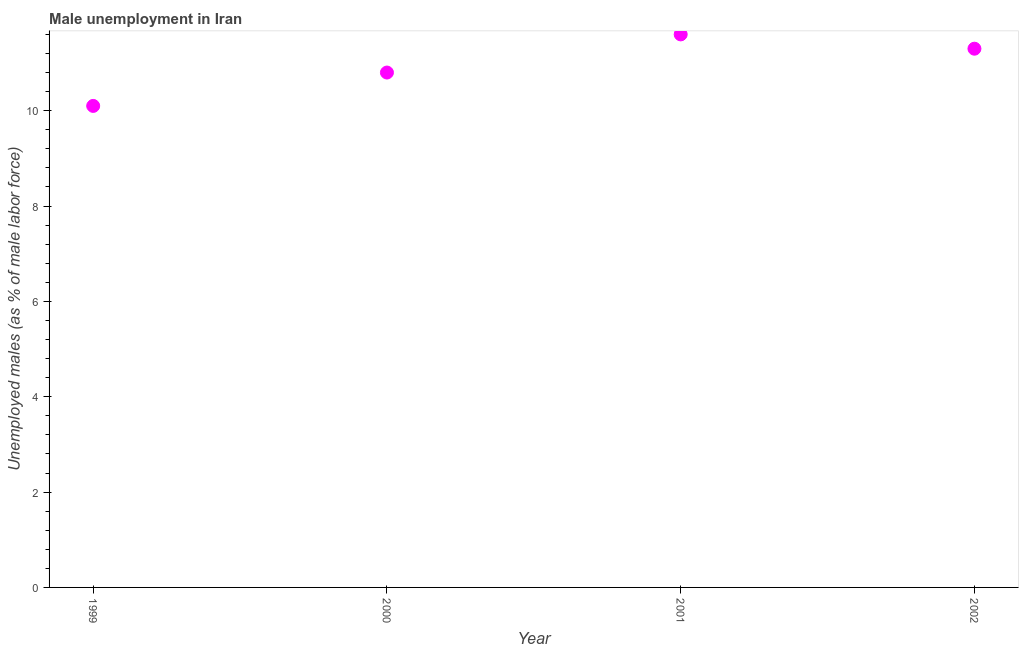What is the unemployed males population in 2001?
Keep it short and to the point. 11.6. Across all years, what is the maximum unemployed males population?
Give a very brief answer. 11.6. Across all years, what is the minimum unemployed males population?
Offer a very short reply. 10.1. In which year was the unemployed males population minimum?
Offer a very short reply. 1999. What is the sum of the unemployed males population?
Keep it short and to the point. 43.8. What is the difference between the unemployed males population in 2001 and 2002?
Keep it short and to the point. 0.3. What is the average unemployed males population per year?
Your answer should be compact. 10.95. What is the median unemployed males population?
Your answer should be compact. 11.05. In how many years, is the unemployed males population greater than 10.8 %?
Offer a terse response. 3. Do a majority of the years between 2000 and 2002 (inclusive) have unemployed males population greater than 1.2000000000000002 %?
Provide a succinct answer. Yes. What is the ratio of the unemployed males population in 2000 to that in 2001?
Your response must be concise. 0.93. What is the difference between the highest and the second highest unemployed males population?
Offer a very short reply. 0.3. What is the difference between the highest and the lowest unemployed males population?
Your answer should be compact. 1.5. How many years are there in the graph?
Make the answer very short. 4. What is the difference between two consecutive major ticks on the Y-axis?
Provide a short and direct response. 2. Does the graph contain any zero values?
Keep it short and to the point. No. Does the graph contain grids?
Provide a short and direct response. No. What is the title of the graph?
Provide a short and direct response. Male unemployment in Iran. What is the label or title of the X-axis?
Provide a succinct answer. Year. What is the label or title of the Y-axis?
Your response must be concise. Unemployed males (as % of male labor force). What is the Unemployed males (as % of male labor force) in 1999?
Ensure brevity in your answer.  10.1. What is the Unemployed males (as % of male labor force) in 2000?
Provide a short and direct response. 10.8. What is the Unemployed males (as % of male labor force) in 2001?
Your answer should be compact. 11.6. What is the Unemployed males (as % of male labor force) in 2002?
Give a very brief answer. 11.3. What is the difference between the Unemployed males (as % of male labor force) in 1999 and 2001?
Your answer should be very brief. -1.5. What is the difference between the Unemployed males (as % of male labor force) in 2000 and 2002?
Keep it short and to the point. -0.5. What is the ratio of the Unemployed males (as % of male labor force) in 1999 to that in 2000?
Provide a short and direct response. 0.94. What is the ratio of the Unemployed males (as % of male labor force) in 1999 to that in 2001?
Your response must be concise. 0.87. What is the ratio of the Unemployed males (as % of male labor force) in 1999 to that in 2002?
Offer a very short reply. 0.89. What is the ratio of the Unemployed males (as % of male labor force) in 2000 to that in 2002?
Offer a terse response. 0.96. 